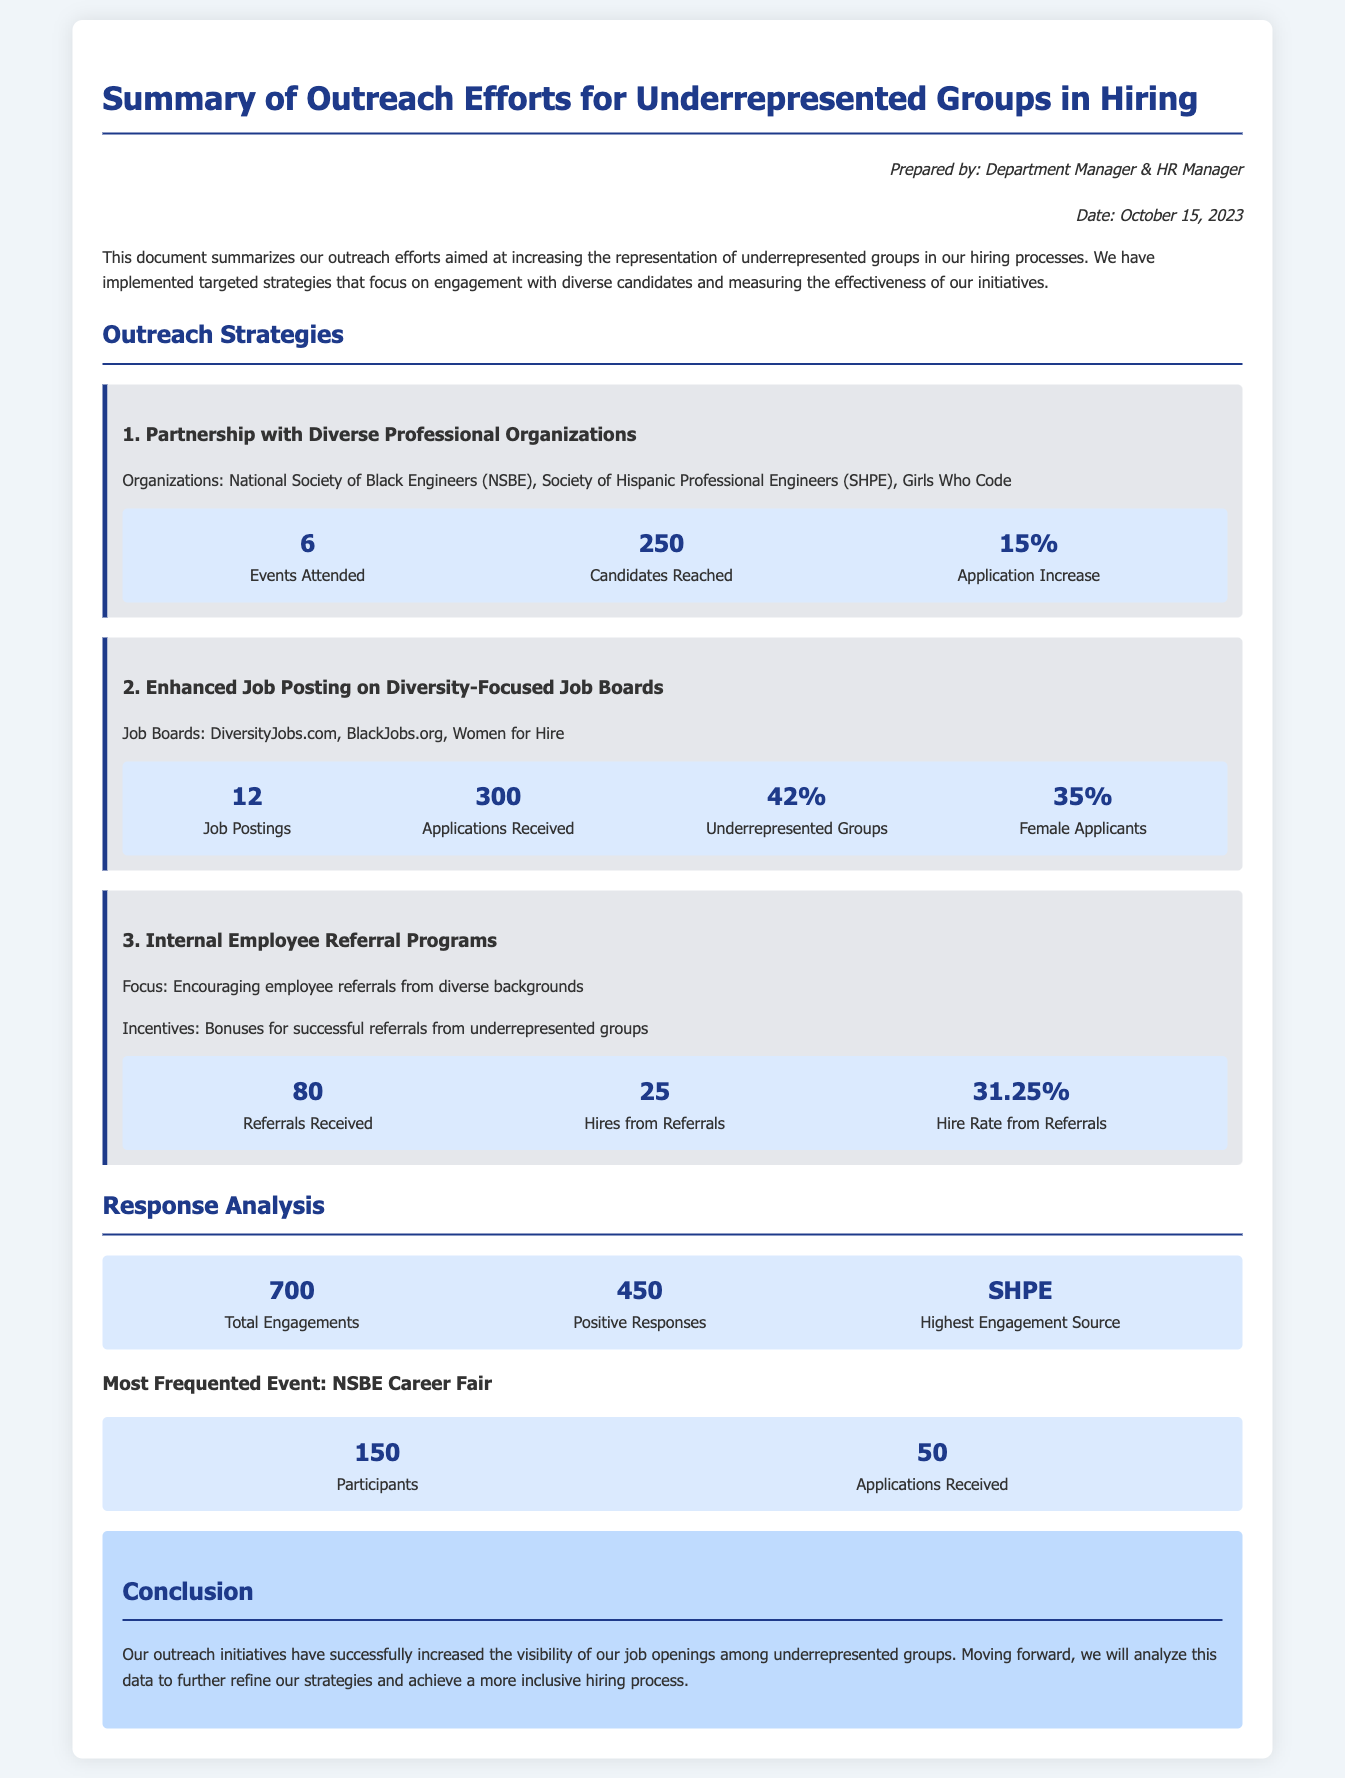What is the date of the document? The document was created on October 15, 2023, as stated in the prepared-by section.
Answer: October 15, 2023 How many events were attended in partnership with diverse professional organizations? The document states that 6 events were attended under this outreach strategy.
Answer: 6 What is the application increase percentage from the partnership with diverse professional organizations? There was a 15% increase in applications mentioned in the outreach strategy for diverse professional organizations.
Answer: 15% What was the total number of applications received from enhanced job postings? The document mentions that 300 applications were received from enhanced job postings.
Answer: 300 Which outreach strategy had the highest engagement source? The highest engagement source was identified as SHPE in the response analysis section.
Answer: SHPE What was the hire rate from internal employee referrals? The hire rate from referrals was noted as 31.25% in the internal employee referral program section.
Answer: 31.25% What was the most frequented event mentioned in the document? The most frequented event is the NSBE Career Fair, highlighted in the response analysis section.
Answer: NSBE Career Fair What metric indicates the total engagements from the outreach efforts? The total engagements metric recorded 700 engagement interactions in the response analysis section.
Answer: 700 How many hires were made from internal employee referrals? The document specifies that there were 25 hires from referrals mentioned in the internal employee referral program.
Answer: 25 